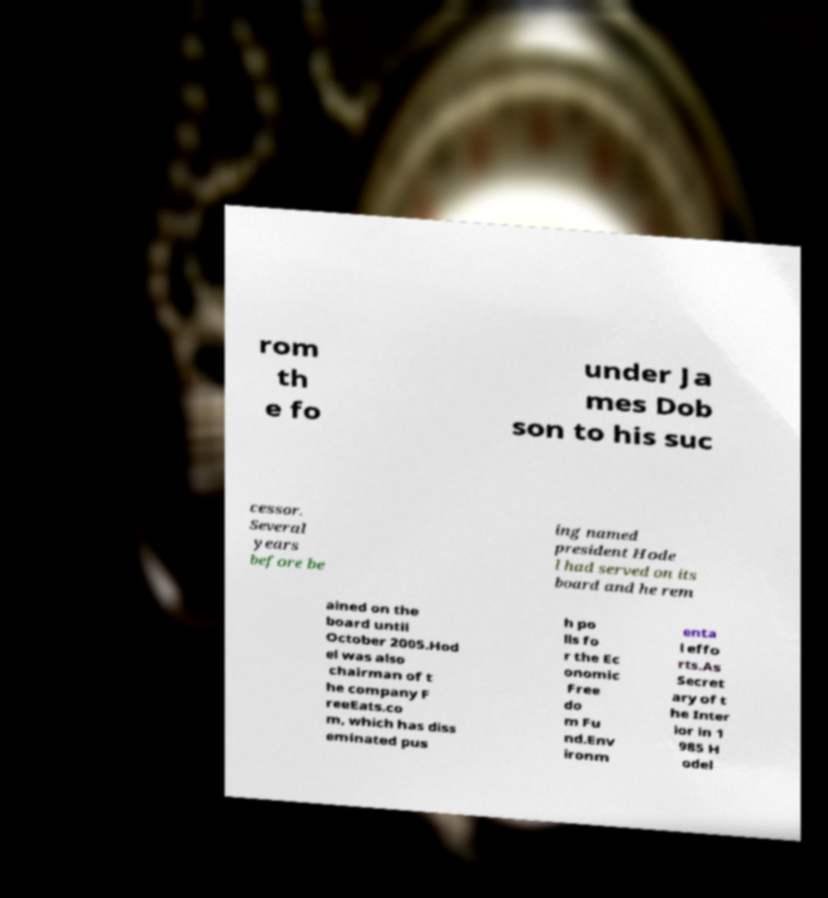For documentation purposes, I need the text within this image transcribed. Could you provide that? rom th e fo under Ja mes Dob son to his suc cessor. Several years before be ing named president Hode l had served on its board and he rem ained on the board until October 2005.Hod el was also chairman of t he company F reeEats.co m, which has diss eminated pus h po lls fo r the Ec onomic Free do m Fu nd.Env ironm enta l effo rts.As Secret ary of t he Inter ior in 1 985 H odel 